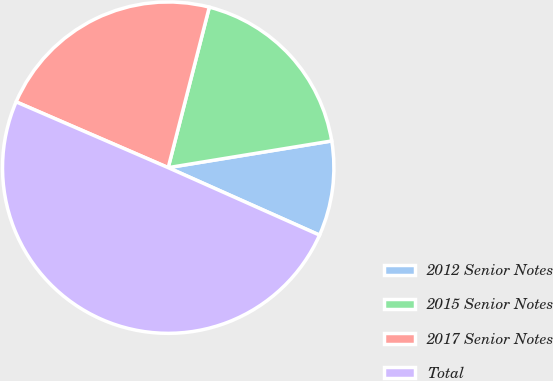<chart> <loc_0><loc_0><loc_500><loc_500><pie_chart><fcel>2012 Senior Notes<fcel>2015 Senior Notes<fcel>2017 Senior Notes<fcel>Total<nl><fcel>9.25%<fcel>18.43%<fcel>22.49%<fcel>49.82%<nl></chart> 